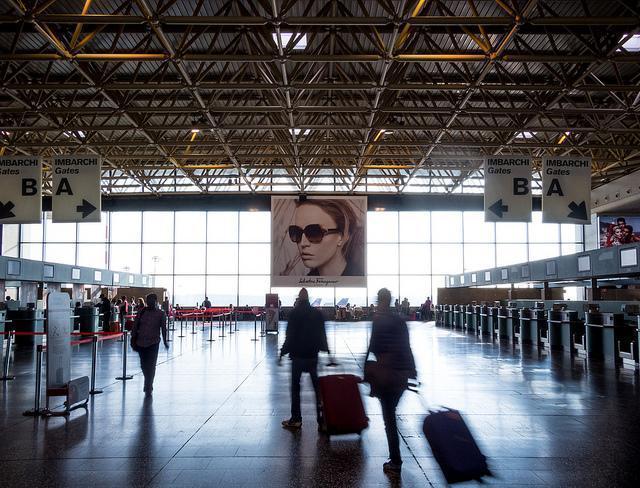This Imbarchi gates are updated as automatic open by using what?
Indicate the correct choice and explain in the format: 'Answer: answer
Rationale: rationale.'
Options: Wood, magnet, cargos, steel. Answer: magnet.
Rationale: They use a magnet. 